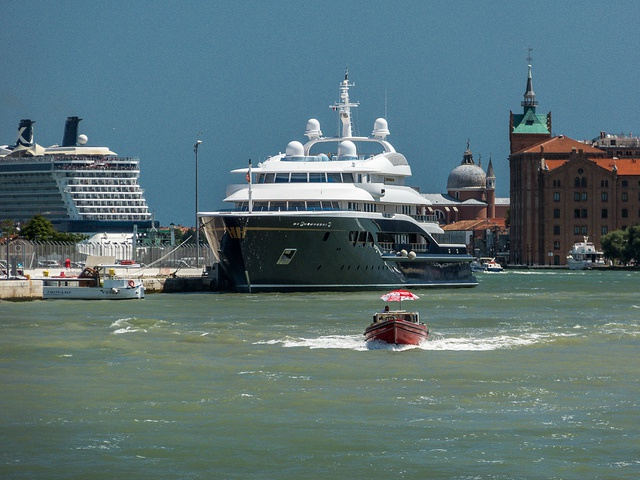Describe the objects in this image and their specific colors. I can see boat in gray, black, lightgray, and darkgray tones, boat in gray, navy, blue, and lightgray tones, boat in gray, lightgray, darkgray, and black tones, boat in gray, black, maroon, and brown tones, and boat in gray, black, darkgray, and blue tones in this image. 